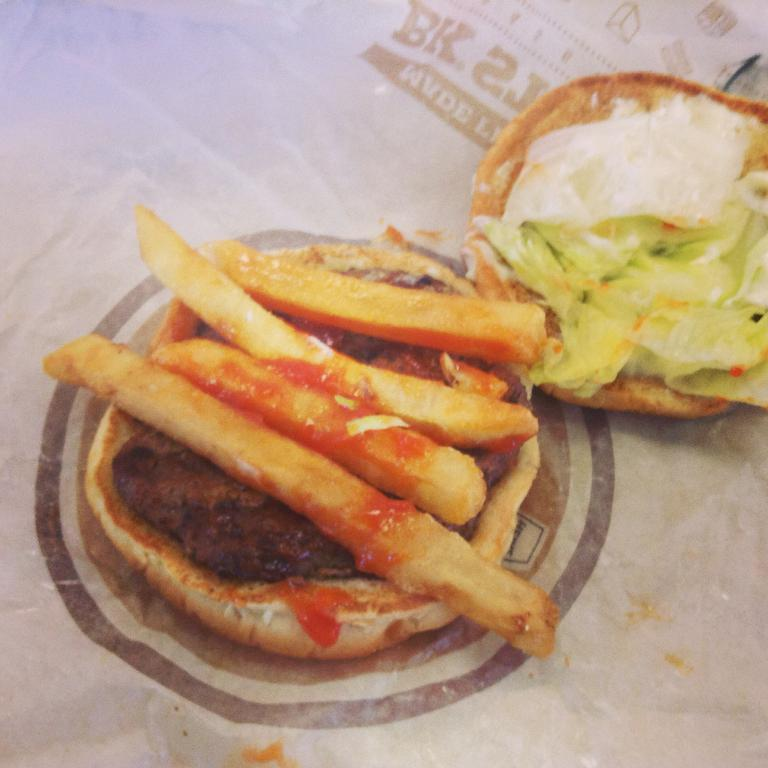What is the main food item in the center of the image? There is a burger in the center of the image. What type of side dish is present in the image? There are french fries in the image. What condiment can be seen in the image? There is sauce in the image. What is the purpose of the paper at the bottom of the image? The paper at the bottom of the image might be used for holding or wrapping the food. How does the burger contribute to the digestion process in the image? The image does not show any digestion process, and the burger's role in digestion cannot be determined from the image. 